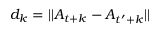<formula> <loc_0><loc_0><loc_500><loc_500>d _ { k } = | | A _ { t + k } - A _ { t ^ { \prime } + k } | |</formula> 